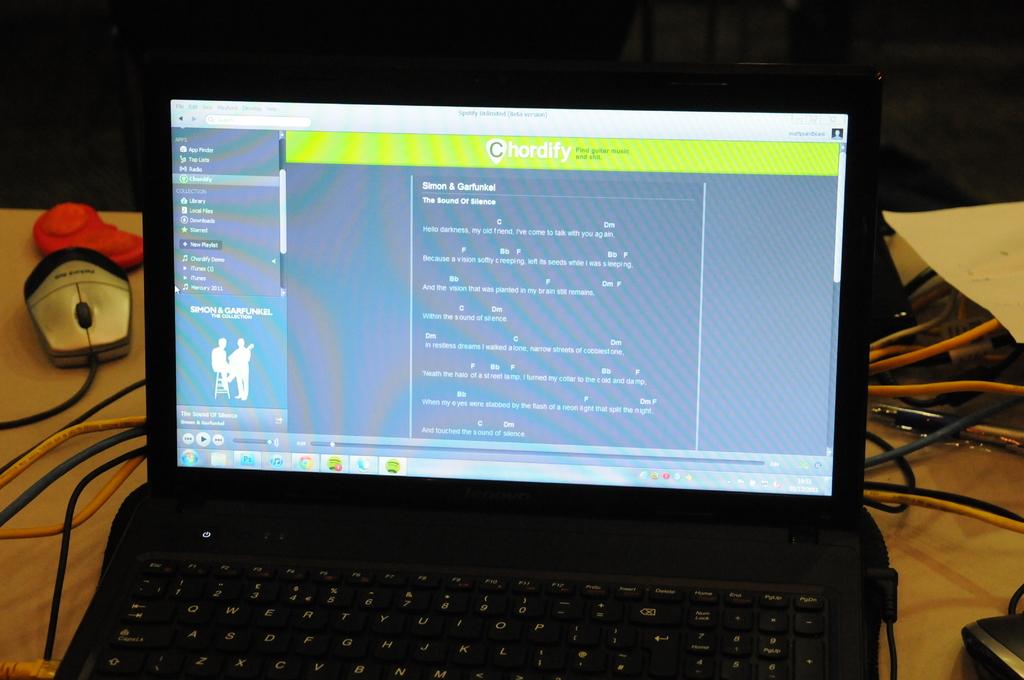What is the site name?
Your answer should be compact. Chordify. 